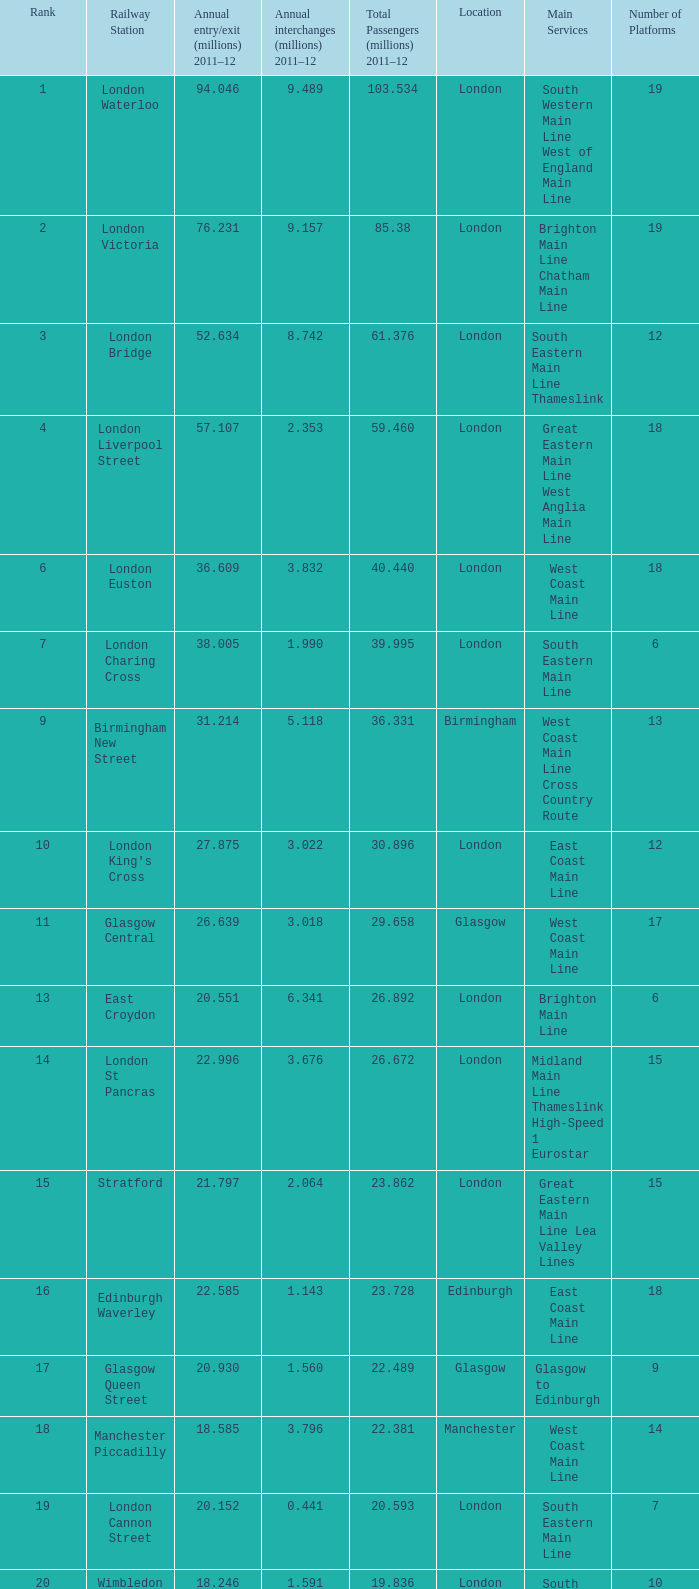During 2011-12, what was the number of annual interchanges in millions when the annual entry/exits amounted to 36.609 million? 3.832. 